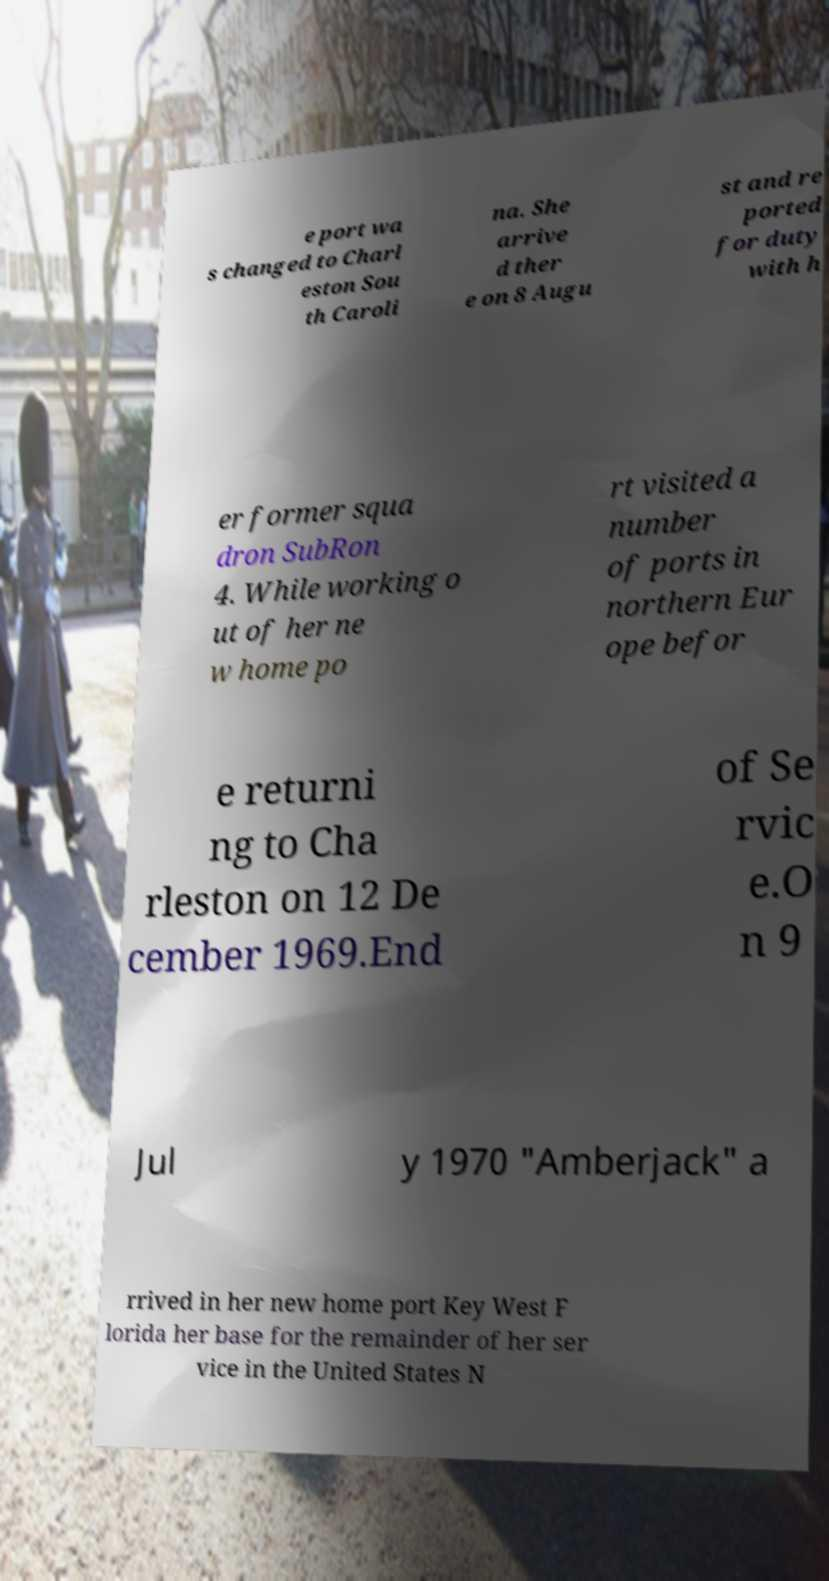Could you assist in decoding the text presented in this image and type it out clearly? e port wa s changed to Charl eston Sou th Caroli na. She arrive d ther e on 8 Augu st and re ported for duty with h er former squa dron SubRon 4. While working o ut of her ne w home po rt visited a number of ports in northern Eur ope befor e returni ng to Cha rleston on 12 De cember 1969.End of Se rvic e.O n 9 Jul y 1970 "Amberjack" a rrived in her new home port Key West F lorida her base for the remainder of her ser vice in the United States N 